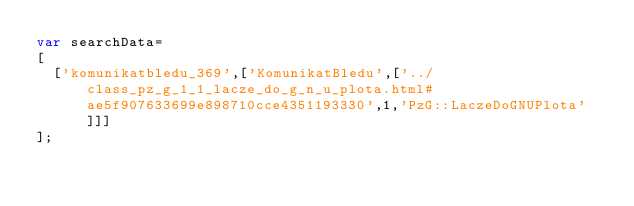<code> <loc_0><loc_0><loc_500><loc_500><_JavaScript_>var searchData=
[
  ['komunikatbledu_369',['KomunikatBledu',['../class_pz_g_1_1_lacze_do_g_n_u_plota.html#ae5f907633699e898710cce4351193330',1,'PzG::LaczeDoGNUPlota']]]
];
</code> 